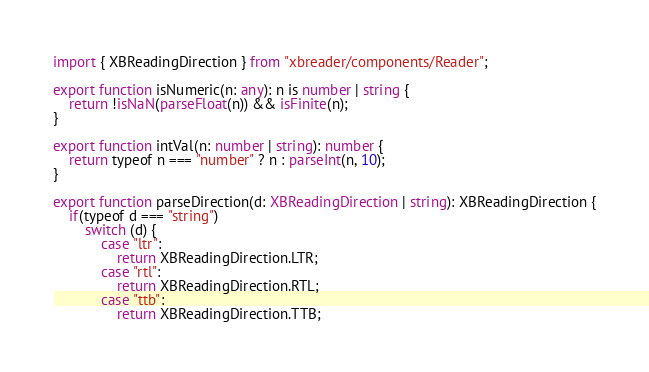Convert code to text. <code><loc_0><loc_0><loc_500><loc_500><_TypeScript_>import { XBReadingDirection } from "xbreader/components/Reader";

export function isNumeric(n: any): n is number | string {
    return !isNaN(parseFloat(n)) && isFinite(n);
}

export function intVal(n: number | string): number {
    return typeof n === "number" ? n : parseInt(n, 10);
}

export function parseDirection(d: XBReadingDirection | string): XBReadingDirection {
    if(typeof d === "string")
        switch (d) {
            case "ltr":
                return XBReadingDirection.LTR;
            case "rtl":
                return XBReadingDirection.RTL;
            case "ttb":
                return XBReadingDirection.TTB;</code> 